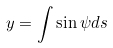<formula> <loc_0><loc_0><loc_500><loc_500>y = \int \sin \psi d s</formula> 